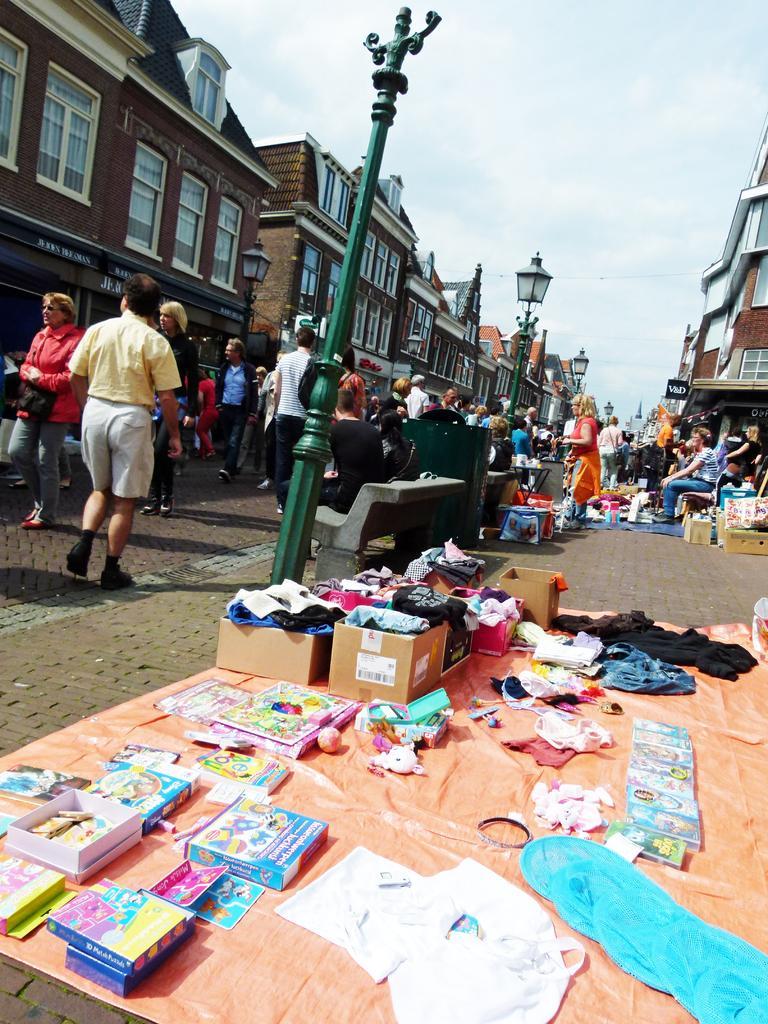In one or two sentences, can you explain what this image depicts? There are books, cartons and other objects on the floor. There are poles, benches and people are present. There are buildings. 